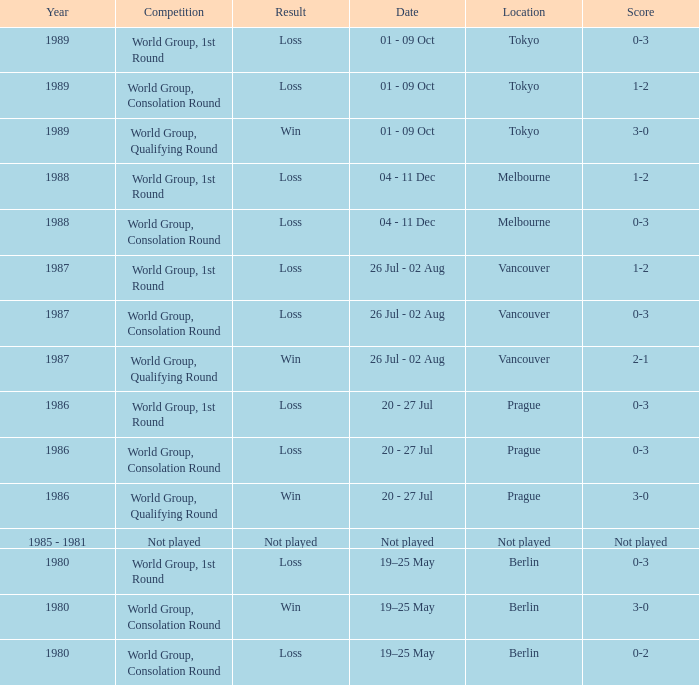Could you parse the entire table? {'header': ['Year', 'Competition', 'Result', 'Date', 'Location', 'Score'], 'rows': [['1989', 'World Group, 1st Round', 'Loss', '01 - 09 Oct', 'Tokyo', '0-3'], ['1989', 'World Group, Consolation Round', 'Loss', '01 - 09 Oct', 'Tokyo', '1-2'], ['1989', 'World Group, Qualifying Round', 'Win', '01 - 09 Oct', 'Tokyo', '3-0'], ['1988', 'World Group, 1st Round', 'Loss', '04 - 11 Dec', 'Melbourne', '1-2'], ['1988', 'World Group, Consolation Round', 'Loss', '04 - 11 Dec', 'Melbourne', '0-3'], ['1987', 'World Group, 1st Round', 'Loss', '26 Jul - 02 Aug', 'Vancouver', '1-2'], ['1987', 'World Group, Consolation Round', 'Loss', '26 Jul - 02 Aug', 'Vancouver', '0-3'], ['1987', 'World Group, Qualifying Round', 'Win', '26 Jul - 02 Aug', 'Vancouver', '2-1'], ['1986', 'World Group, 1st Round', 'Loss', '20 - 27 Jul', 'Prague', '0-3'], ['1986', 'World Group, Consolation Round', 'Loss', '20 - 27 Jul', 'Prague', '0-3'], ['1986', 'World Group, Qualifying Round', 'Win', '20 - 27 Jul', 'Prague', '3-0'], ['1985 - 1981', 'Not played', 'Not played', 'Not played', 'Not played', 'Not played'], ['1980', 'World Group, 1st Round', 'Loss', '19–25 May', 'Berlin', '0-3'], ['1980', 'World Group, Consolation Round', 'Win', '19–25 May', 'Berlin', '3-0'], ['1980', 'World Group, Consolation Round', 'Loss', '19–25 May', 'Berlin', '0-2']]} What is the competition in tokyo with the result loss? World Group, 1st Round, World Group, Consolation Round. 